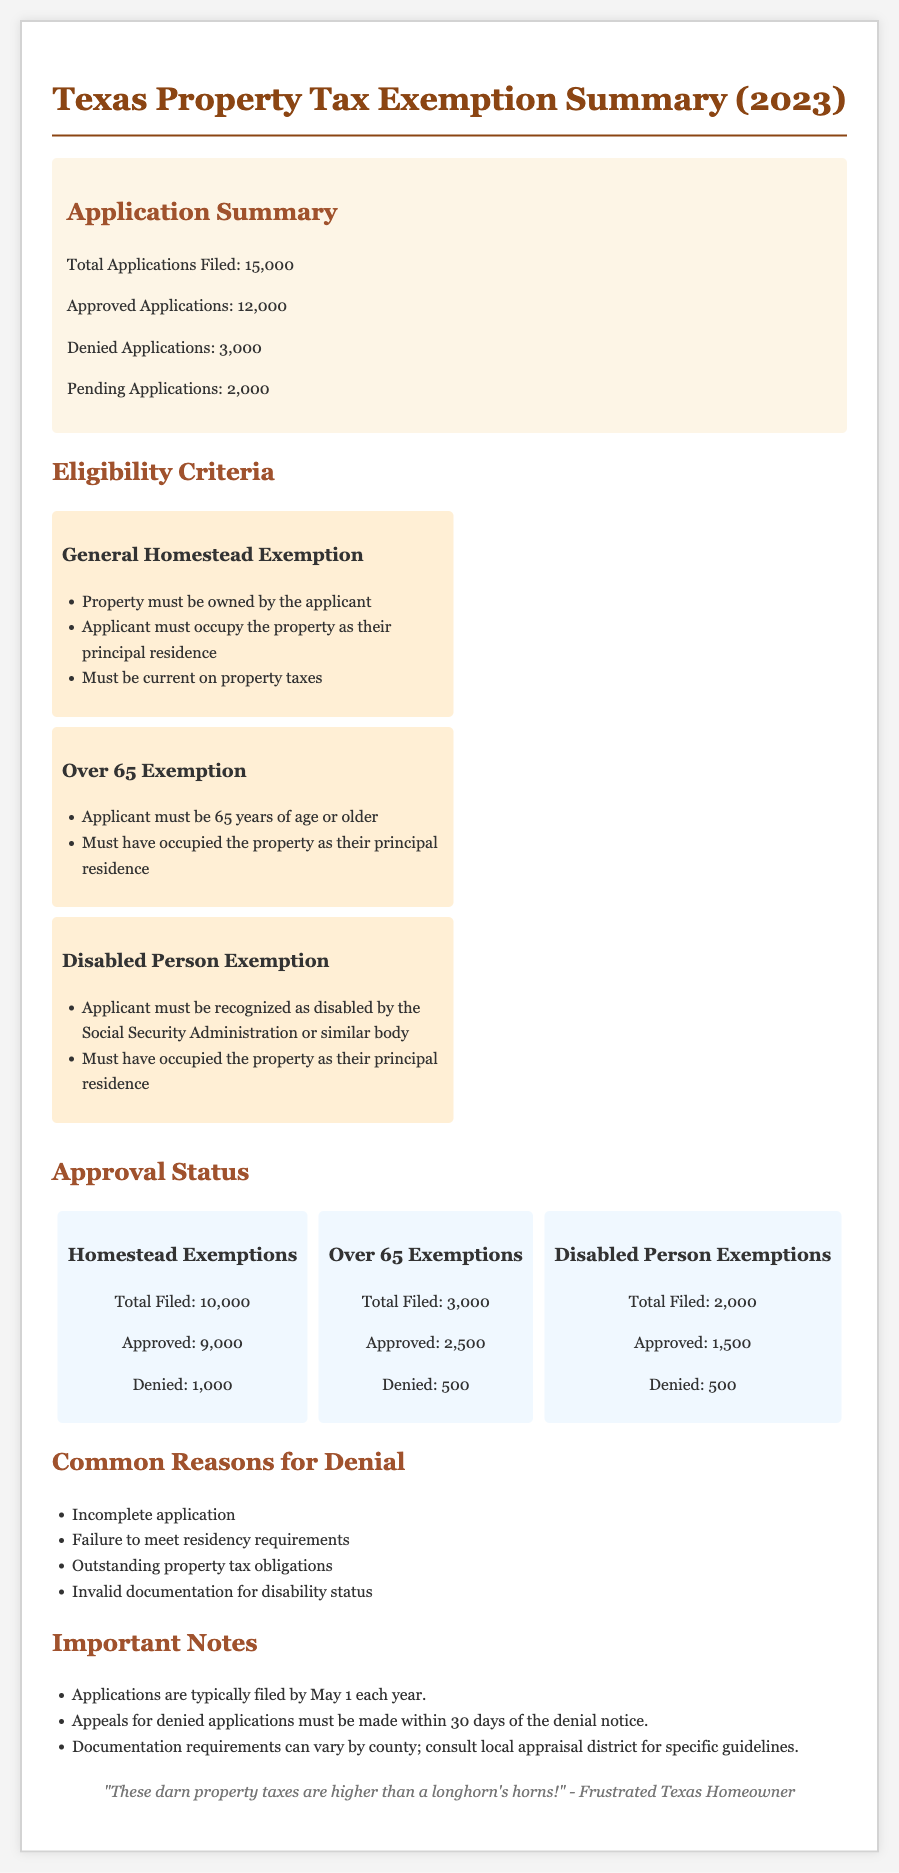what is the total number of applications filed? The total number of applications filed is mentioned as 15,000 in the document.
Answer: 15,000 how many approved applications are there for Homestead Exemptions? The number of approved applications specifically for Homestead Exemptions is stated as 9,000.
Answer: 9,000 what is one eligibility criterion for the Disabled Person Exemption? One of the eligibility criteria mentioned is that the applicant must be recognized as disabled by the Social Security Administration or similar body.
Answer: recognized as disabled how many applications are pending? The document mentions there are 2,000 pending applications.
Answer: 2,000 what percentage of Over 65 Exemption applications were approved? The approval rate for Over 65 Exemption applications is calculated as 2,500 approved out of 3,000 filed, which is approximately 83.33%.
Answer: 83.33% what is a common reason for denial of applications? One common reason for denial mentioned is "Incomplete application."
Answer: Incomplete application how many denied applications are there for Disabled Person Exemptions? The document states that there are 500 denied applications for Disabled Person Exemptions.
Answer: 500 when must applications typically be filed? The document specifies that applications are typically filed by May 1 each year.
Answer: May 1 what is the total number of denied applications? The total number of denied applications is calculated as 3,000 from the summary section.
Answer: 3,000 what is the application status for Homestead Exemptions? The document states there are a total of 10,000 filed applications for Homestead Exemptions with 9,000 approved and 1,000 denied.
Answer: 10,000 filed, 9,000 approved, 1,000 denied 